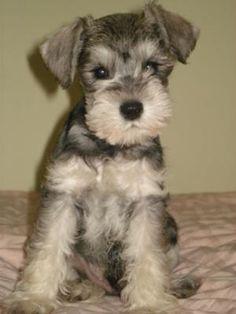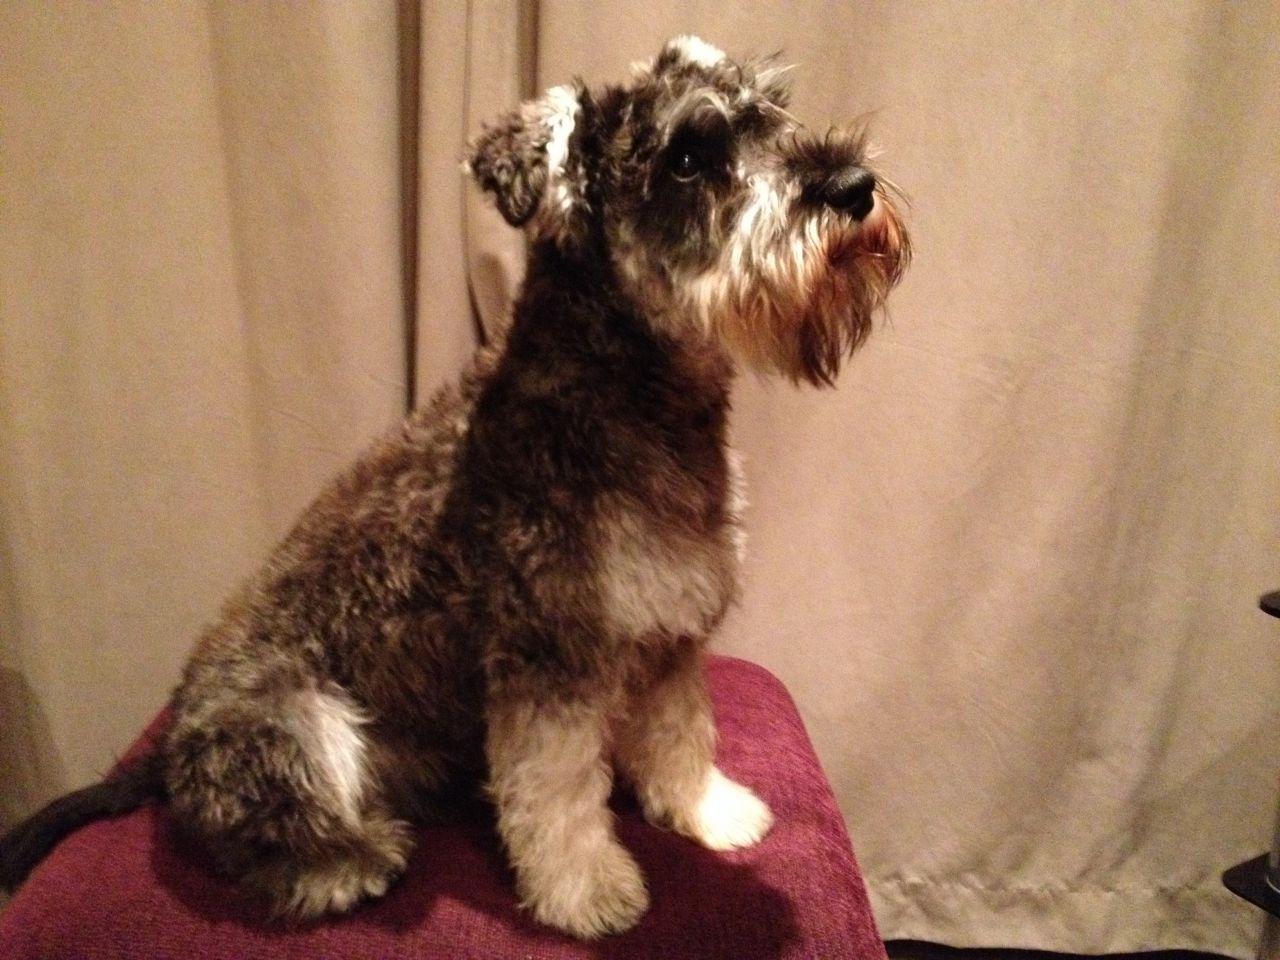The first image is the image on the left, the second image is the image on the right. Considering the images on both sides, is "Exactly one dog is sitting." valid? Answer yes or no. No. 